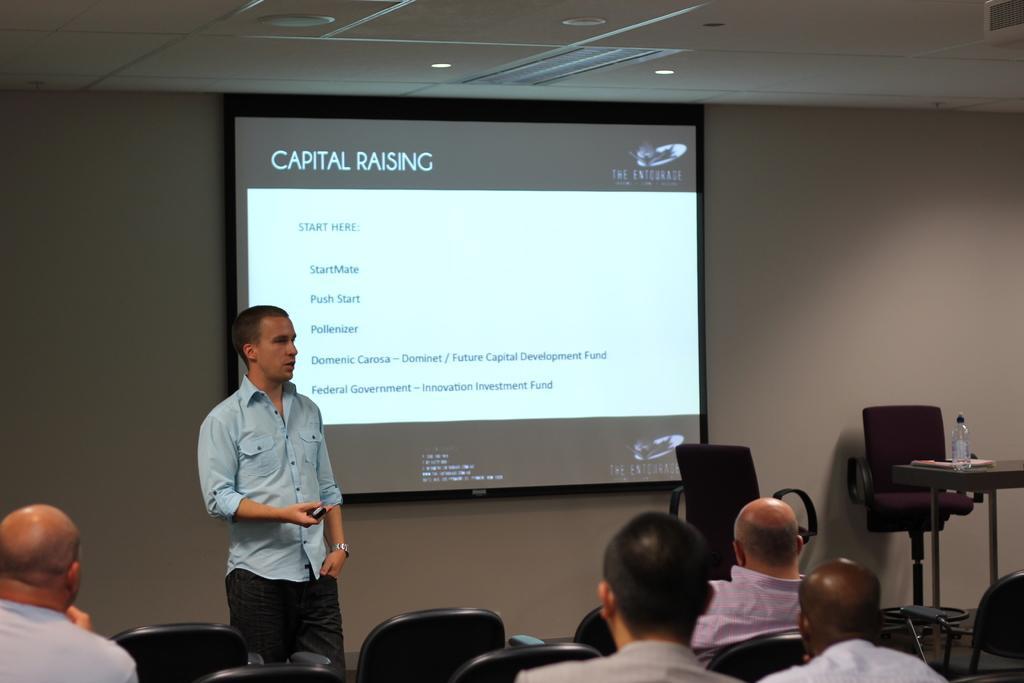Could you give a brief overview of what you see in this image? Bottom of the image few people are sitting on chairs. In the middle of the image a man is standing and holding something in his hand. Behind him there is a wall, on the wall there is a screen. Top of the image there is roof and lights. Bottom right side of the image there is a table, on the table there are some books and bottle. Behind the table there are some chairs. 